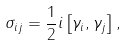Convert formula to latex. <formula><loc_0><loc_0><loc_500><loc_500>\sigma _ { i j } = \frac { 1 } { 2 } i \left [ \gamma _ { i } , \gamma _ { j } \right ] ,</formula> 